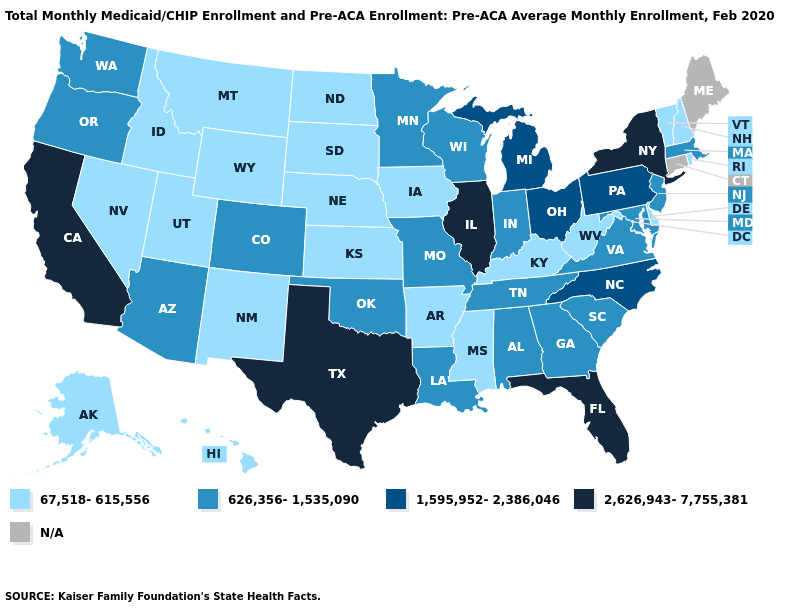What is the value of New Hampshire?
Give a very brief answer. 67,518-615,556. Name the states that have a value in the range 2,626,943-7,755,381?
Keep it brief. California, Florida, Illinois, New York, Texas. Does New York have the highest value in the Northeast?
Concise answer only. Yes. Does the map have missing data?
Short answer required. Yes. What is the value of Virginia?
Concise answer only. 626,356-1,535,090. What is the value of Maryland?
Give a very brief answer. 626,356-1,535,090. What is the value of North Dakota?
Answer briefly. 67,518-615,556. Name the states that have a value in the range N/A?
Short answer required. Connecticut, Maine. What is the highest value in states that border New Jersey?
Keep it brief. 2,626,943-7,755,381. Which states have the lowest value in the USA?
Answer briefly. Alaska, Arkansas, Delaware, Hawaii, Idaho, Iowa, Kansas, Kentucky, Mississippi, Montana, Nebraska, Nevada, New Hampshire, New Mexico, North Dakota, Rhode Island, South Dakota, Utah, Vermont, West Virginia, Wyoming. What is the value of Louisiana?
Concise answer only. 626,356-1,535,090. 